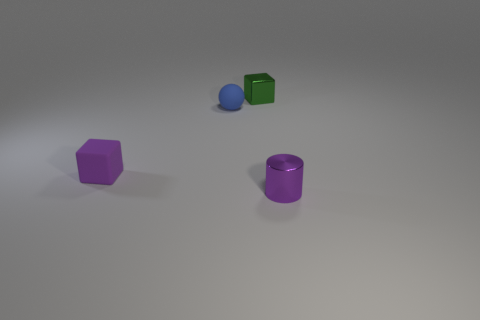There is a thing that is behind the small rubber cube and left of the green block; what is its size?
Make the answer very short. Small. Are there more tiny matte spheres to the left of the blue thing than large gray matte cubes?
Your answer should be compact. No. How many cubes are purple objects or blue matte things?
Your response must be concise. 1. The small thing that is behind the purple block and to the left of the tiny shiny block has what shape?
Give a very brief answer. Sphere. Are there the same number of small objects that are in front of the small blue ball and tiny spheres that are behind the small purple metallic cylinder?
Keep it short and to the point. No. How many things are blue rubber spheres or big gray shiny blocks?
Ensure brevity in your answer.  1. What is the color of the metallic block that is the same size as the ball?
Give a very brief answer. Green. What number of things are either matte objects behind the purple matte object or purple objects that are on the right side of the tiny rubber block?
Give a very brief answer. 2. Are there an equal number of green cubes that are in front of the small purple metallic cylinder and small rubber cubes?
Your answer should be very brief. No. Do the matte object on the right side of the purple matte thing and the purple thing that is to the right of the green cube have the same size?
Your response must be concise. Yes. 